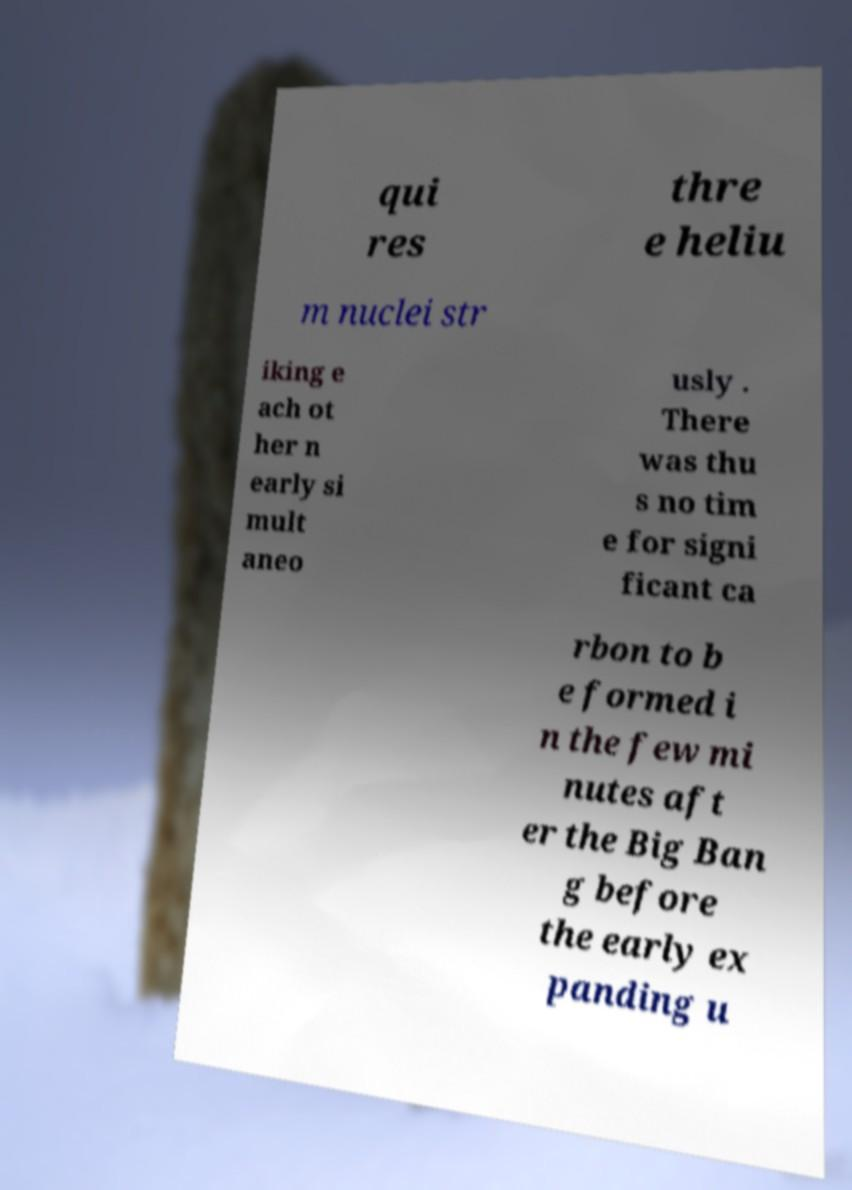Could you extract and type out the text from this image? qui res thre e heliu m nuclei str iking e ach ot her n early si mult aneo usly . There was thu s no tim e for signi ficant ca rbon to b e formed i n the few mi nutes aft er the Big Ban g before the early ex panding u 